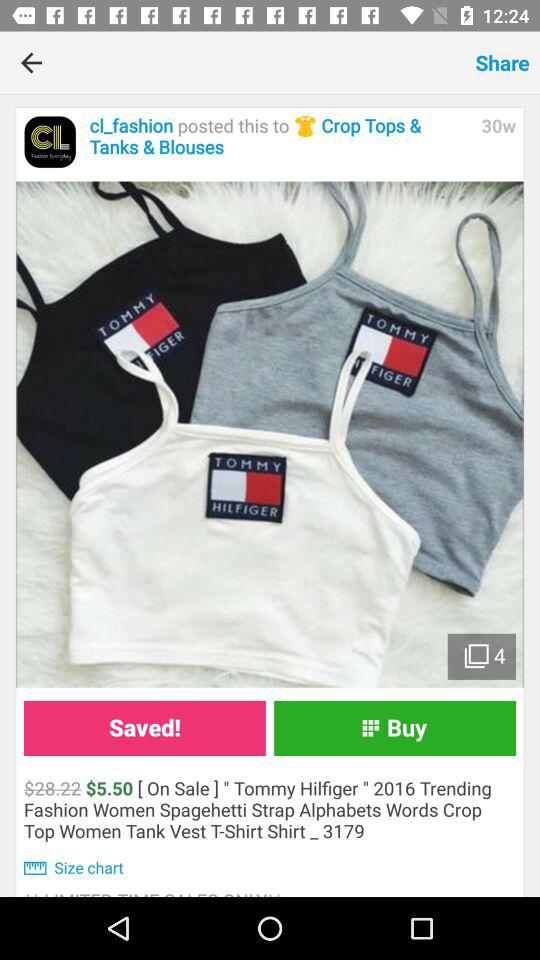How many weeks ago was the post posted? The post was posted 30 weeks ago. 